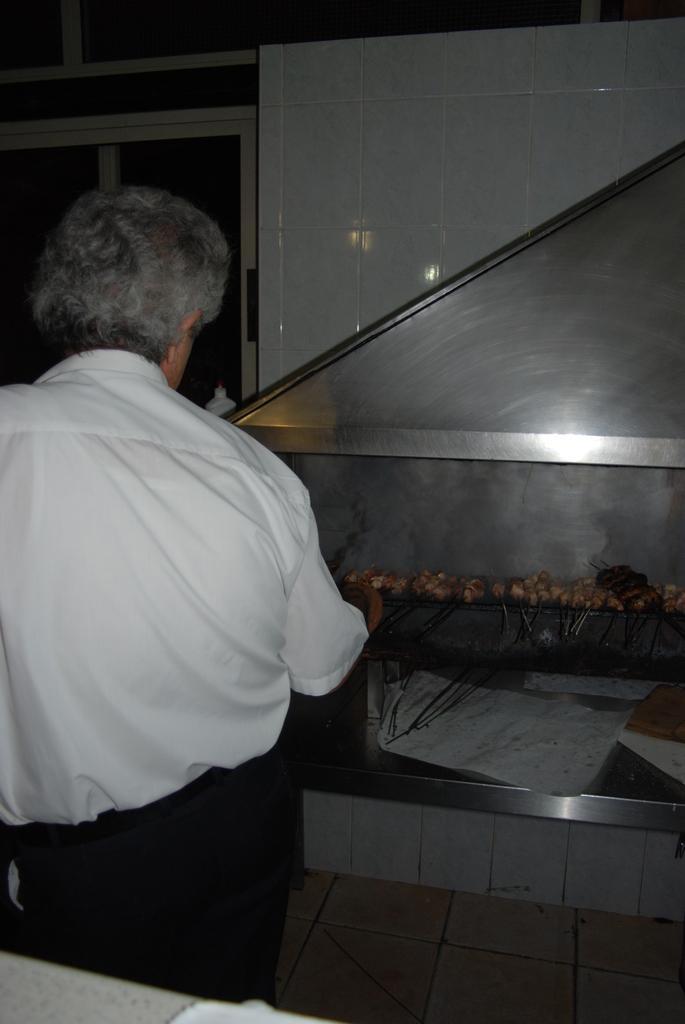Could you give a brief overview of what you see in this image? In this image, on the left side there is a man cooking some food and he wearing white and black dress. 